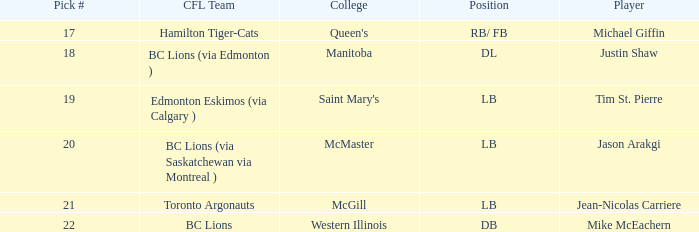Could you parse the entire table? {'header': ['Pick #', 'CFL Team', 'College', 'Position', 'Player'], 'rows': [['17', 'Hamilton Tiger-Cats', "Queen's", 'RB/ FB', 'Michael Giffin'], ['18', 'BC Lions (via Edmonton )', 'Manitoba', 'DL', 'Justin Shaw'], ['19', 'Edmonton Eskimos (via Calgary )', "Saint Mary's", 'LB', 'Tim St. Pierre'], ['20', 'BC Lions (via Saskatchewan via Montreal )', 'McMaster', 'LB', 'Jason Arakgi'], ['21', 'Toronto Argonauts', 'McGill', 'LB', 'Jean-Nicolas Carriere'], ['22', 'BC Lions', 'Western Illinois', 'DB', 'Mike McEachern']]} What college does Jean-Nicolas Carriere play for? McGill. 